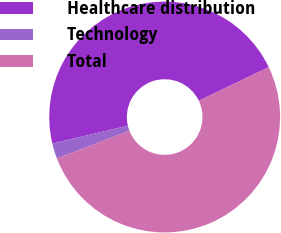Convert chart to OTSL. <chart><loc_0><loc_0><loc_500><loc_500><pie_chart><fcel>Healthcare distribution<fcel>Technology<fcel>Total<nl><fcel>46.58%<fcel>2.18%<fcel>51.24%<nl></chart> 